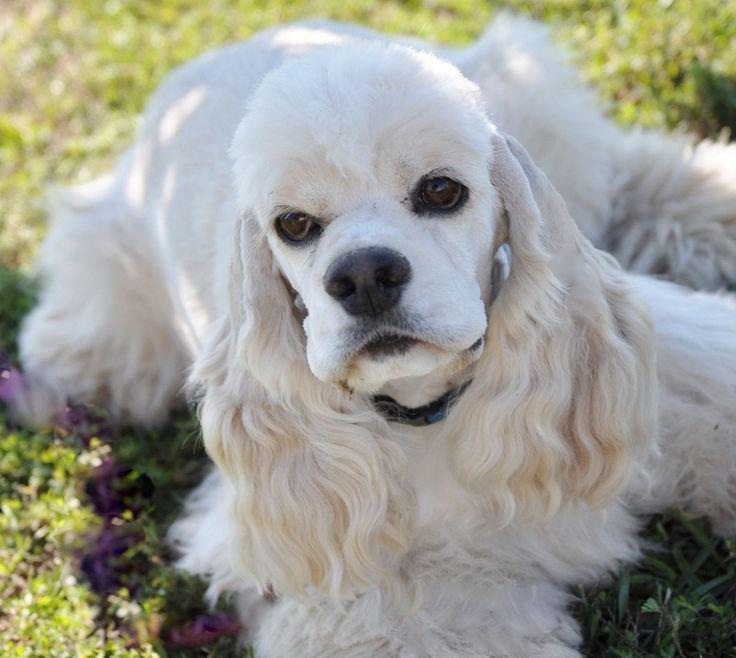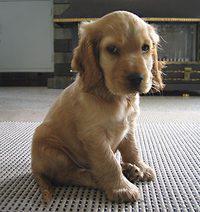The first image is the image on the left, the second image is the image on the right. Analyze the images presented: Is the assertion "An image contains a human holding a dog." valid? Answer yes or no. No. The first image is the image on the left, the second image is the image on the right. Analyze the images presented: Is the assertion "In one of the images, a human hand can be seen touching a single dog." valid? Answer yes or no. No. 